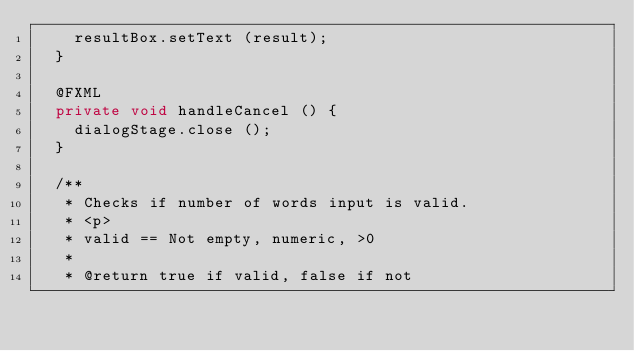<code> <loc_0><loc_0><loc_500><loc_500><_Java_>		resultBox.setText (result);
	}

	@FXML
	private void handleCancel () {
		dialogStage.close ();
	}

	/**
	 * Checks if number of words input is valid.
	 * <p>
	 * valid == Not empty, numeric, >0
	 *
	 * @return true if valid, false if not</code> 